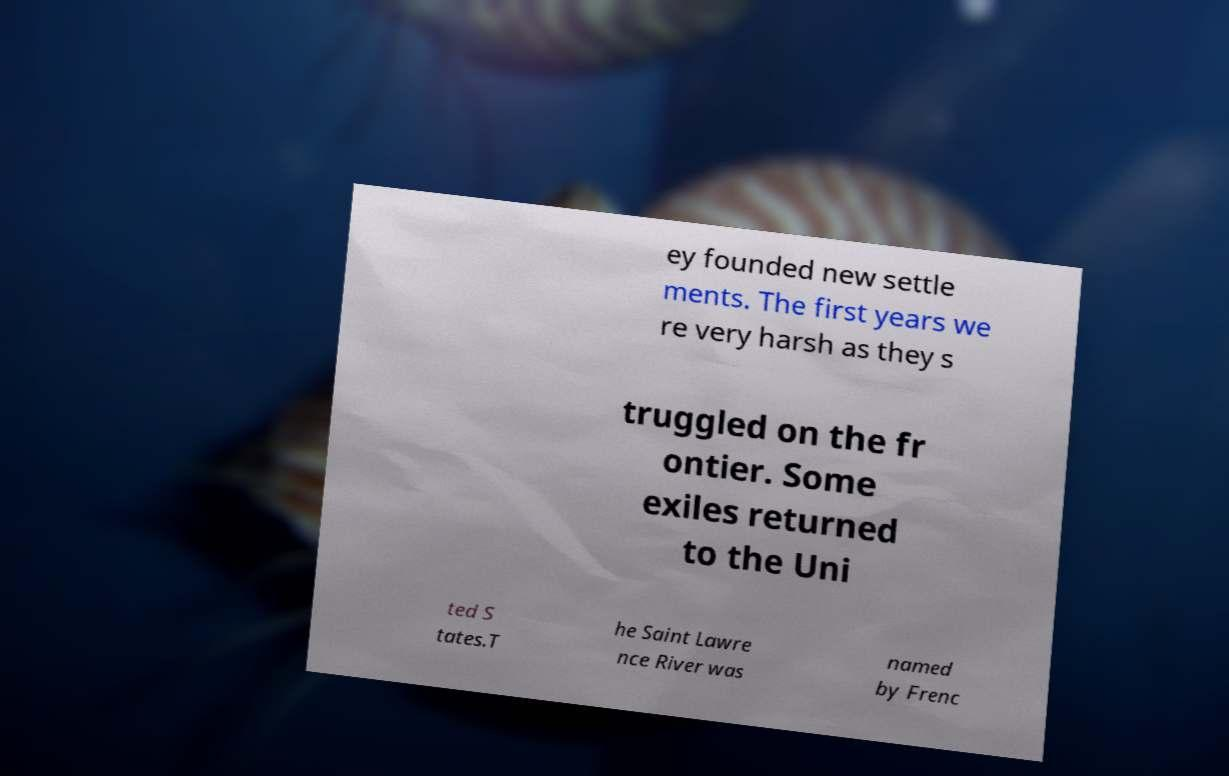For documentation purposes, I need the text within this image transcribed. Could you provide that? ey founded new settle ments. The first years we re very harsh as they s truggled on the fr ontier. Some exiles returned to the Uni ted S tates.T he Saint Lawre nce River was named by Frenc 